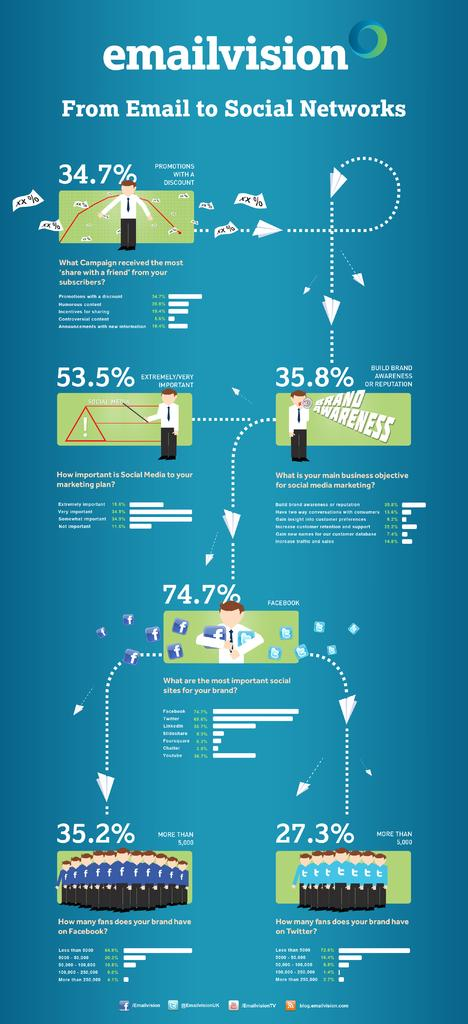What type of content is shown on the image? The image appears to be a presentation slide. What specific information is displayed on the slide? There are percentages displayed on the slide. What is the title of the presentation slide? The slide is titled "Email vision." How many people are in the group shown in the image? There is no group of people present in the image; it is a presentation slide with percentages and a title. What emotion is being expressed by the sock in the image? There is no sock present in the image, and therefore no emotion can be attributed to it. 